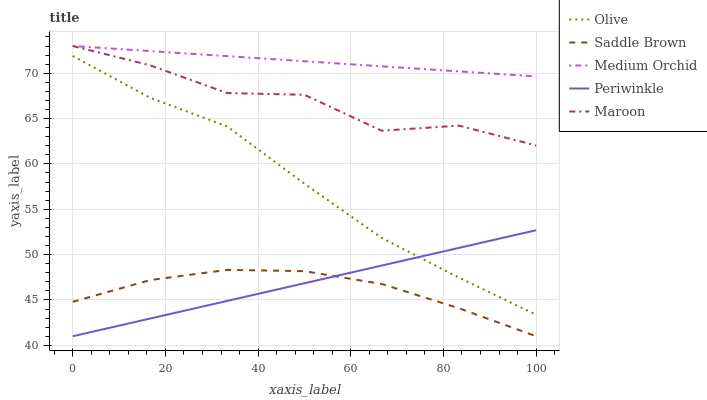Does Periwinkle have the minimum area under the curve?
Answer yes or no. No. Does Periwinkle have the maximum area under the curve?
Answer yes or no. No. Is Periwinkle the smoothest?
Answer yes or no. No. Is Periwinkle the roughest?
Answer yes or no. No. Does Medium Orchid have the lowest value?
Answer yes or no. No. Does Periwinkle have the highest value?
Answer yes or no. No. Is Olive less than Maroon?
Answer yes or no. Yes. Is Maroon greater than Periwinkle?
Answer yes or no. Yes. Does Olive intersect Maroon?
Answer yes or no. No. 